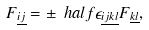<formula> <loc_0><loc_0><loc_500><loc_500>F _ { \underline { i j } } = \pm \ h a l f \epsilon _ { \underline { i j k l } } F _ { \underline { k l } } ,</formula> 